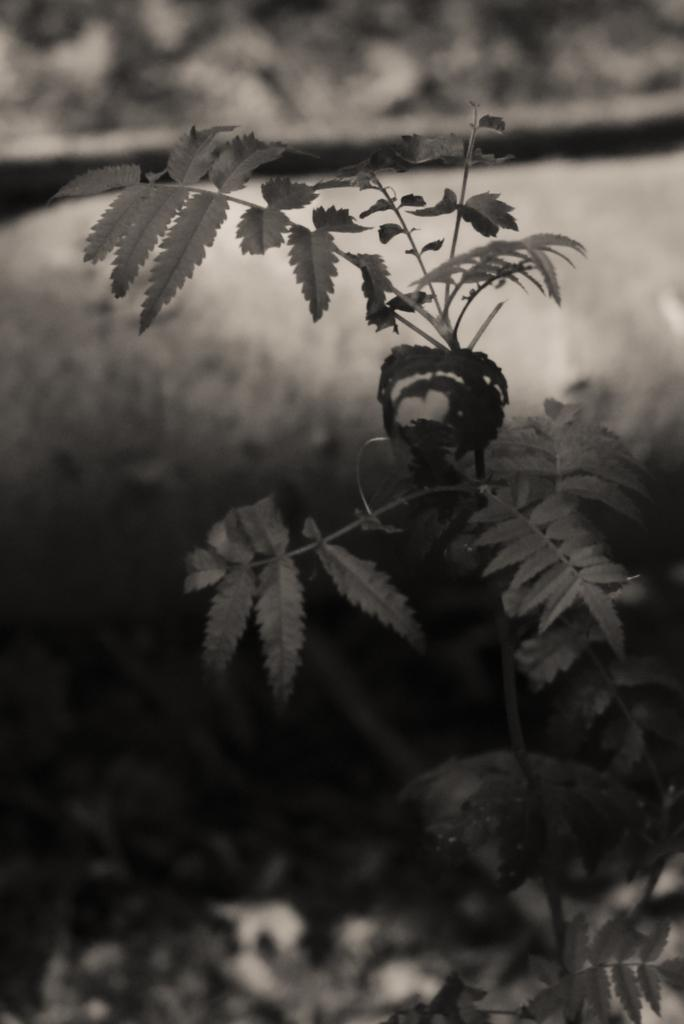What is located in the front of the image? There are plants in the front of the image. Can you describe the background of the image? The background of the image is blurry. How many babies are swinging on the jewel in the image? There are no babies, swing, or jewel present in the image. 